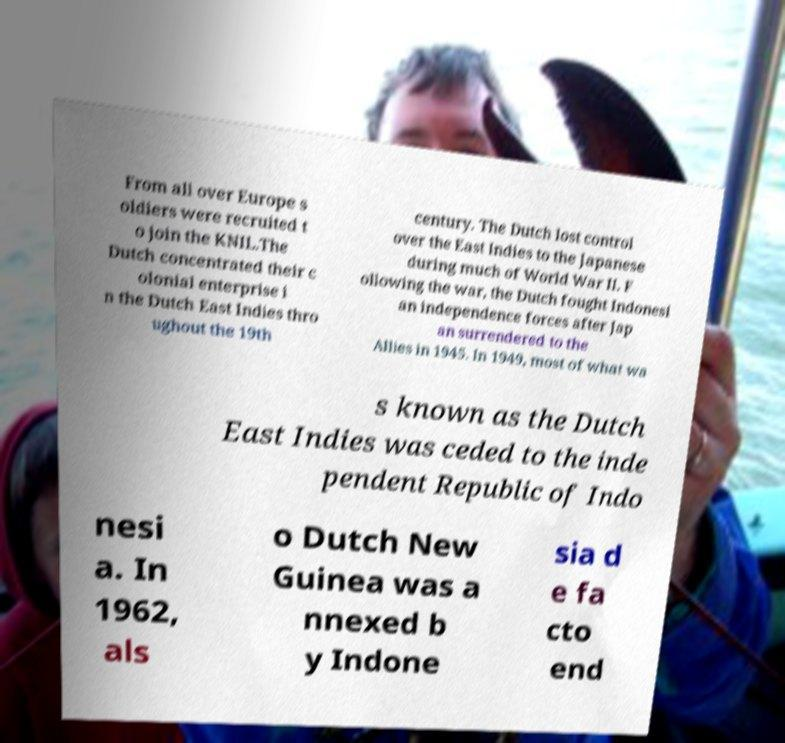For documentation purposes, I need the text within this image transcribed. Could you provide that? From all over Europe s oldiers were recruited t o join the KNIL.The Dutch concentrated their c olonial enterprise i n the Dutch East Indies thro ughout the 19th century. The Dutch lost control over the East Indies to the Japanese during much of World War II. F ollowing the war, the Dutch fought Indonesi an independence forces after Jap an surrendered to the Allies in 1945. In 1949, most of what wa s known as the Dutch East Indies was ceded to the inde pendent Republic of Indo nesi a. In 1962, als o Dutch New Guinea was a nnexed b y Indone sia d e fa cto end 